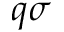<formula> <loc_0><loc_0><loc_500><loc_500>q \sigma</formula> 